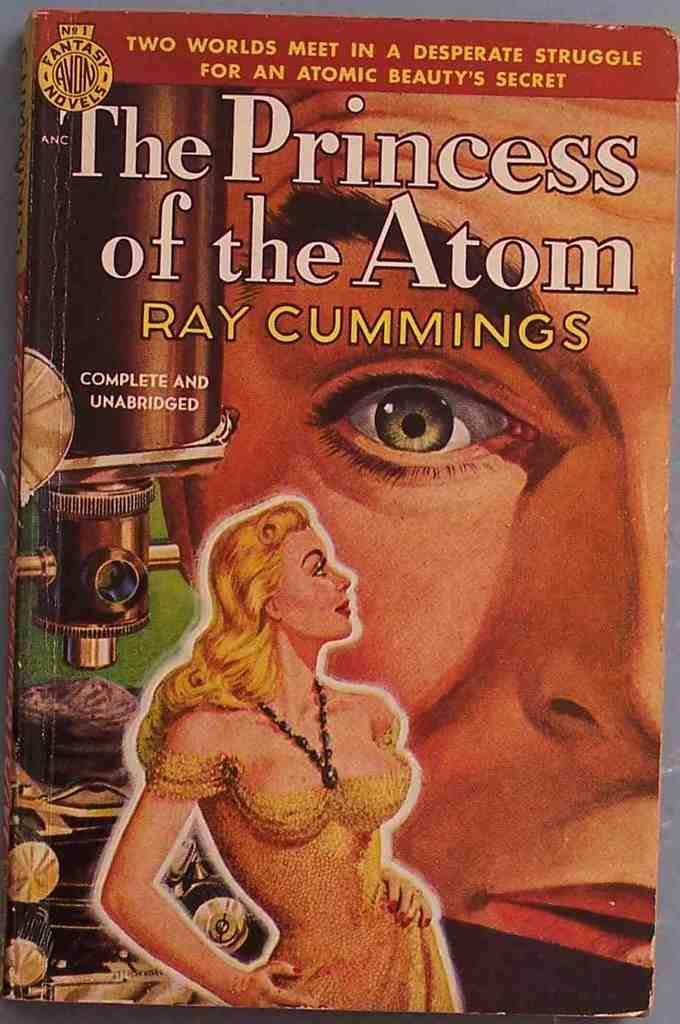<image>
Write a terse but informative summary of the picture. The Princess of the Atom, written by Ray Cummings, is shown in its unabridged version. 